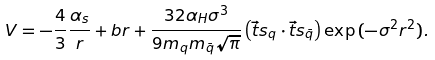Convert formula to latex. <formula><loc_0><loc_0><loc_500><loc_500>V = - \frac { 4 } { 3 } \frac { \alpha _ { s } } { r } + b r + \frac { 3 2 \alpha _ { H } \sigma ^ { 3 } } { 9 m _ { q } m _ { \bar { q } } \sqrt { \pi } } \left ( \vec { t } { s _ { q } } \cdot \vec { t } { s _ { \bar { q } } } \right ) \exp { ( - \sigma ^ { 2 } r ^ { 2 } ) } .</formula> 